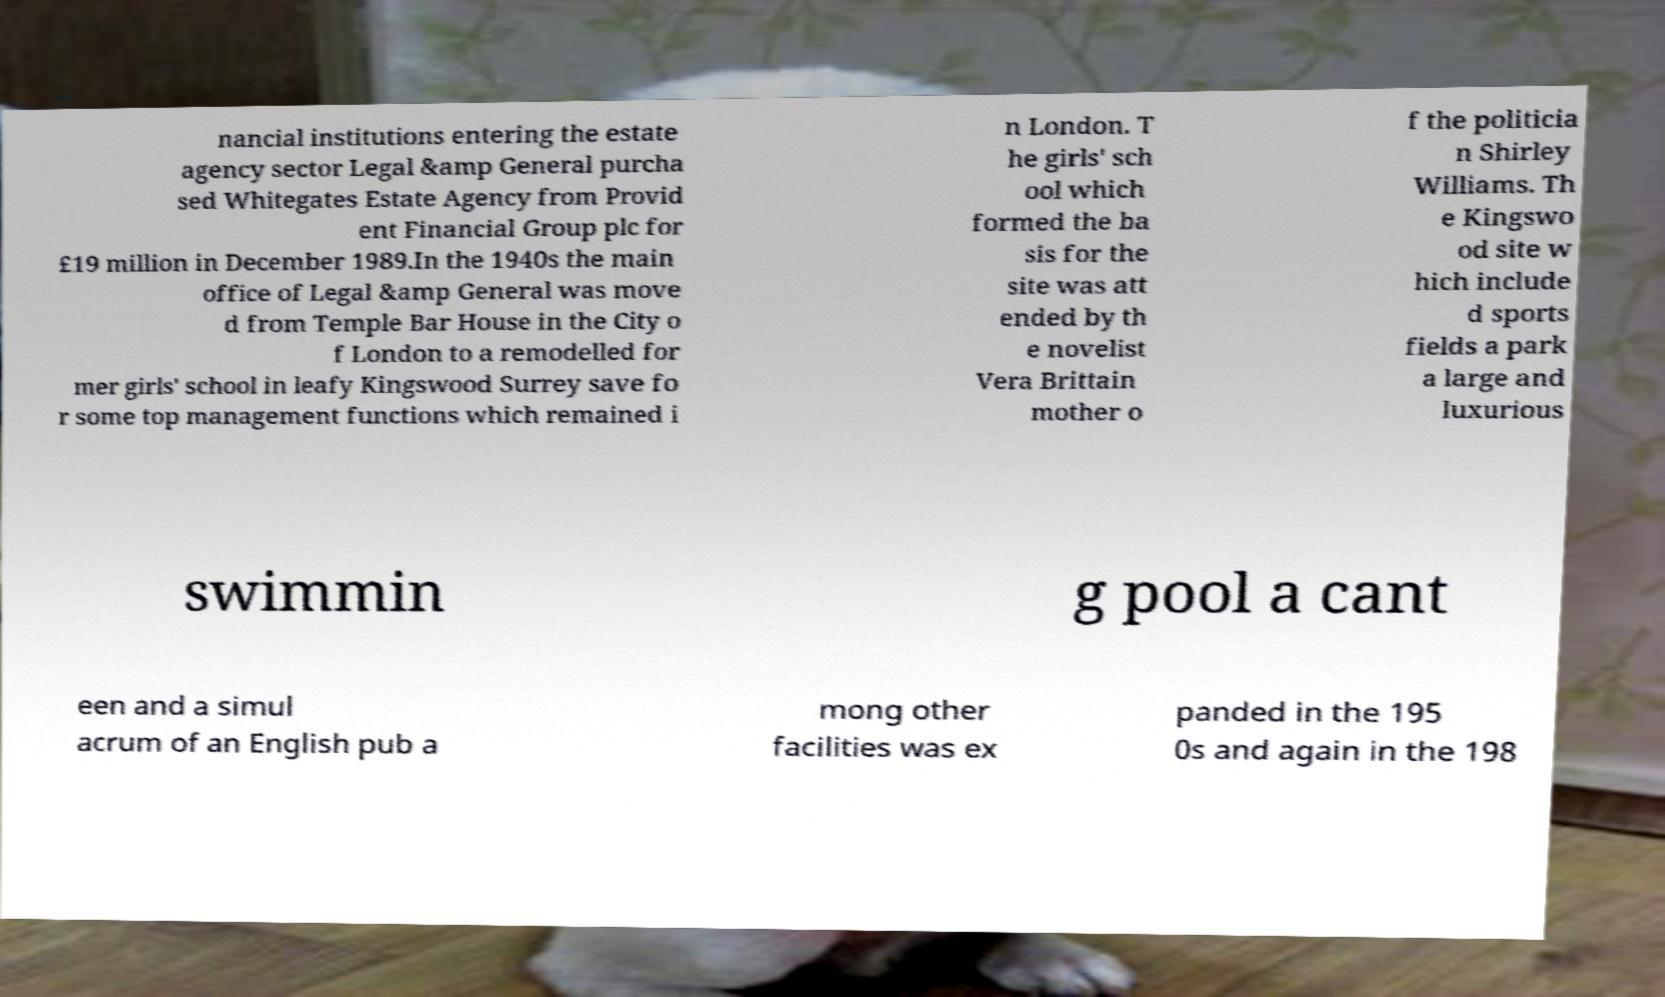Please identify and transcribe the text found in this image. nancial institutions entering the estate agency sector Legal &amp General purcha sed Whitegates Estate Agency from Provid ent Financial Group plc for £19 million in December 1989.In the 1940s the main office of Legal &amp General was move d from Temple Bar House in the City o f London to a remodelled for mer girls' school in leafy Kingswood Surrey save fo r some top management functions which remained i n London. T he girls' sch ool which formed the ba sis for the site was att ended by th e novelist Vera Brittain mother o f the politicia n Shirley Williams. Th e Kingswo od site w hich include d sports fields a park a large and luxurious swimmin g pool a cant een and a simul acrum of an English pub a mong other facilities was ex panded in the 195 0s and again in the 198 